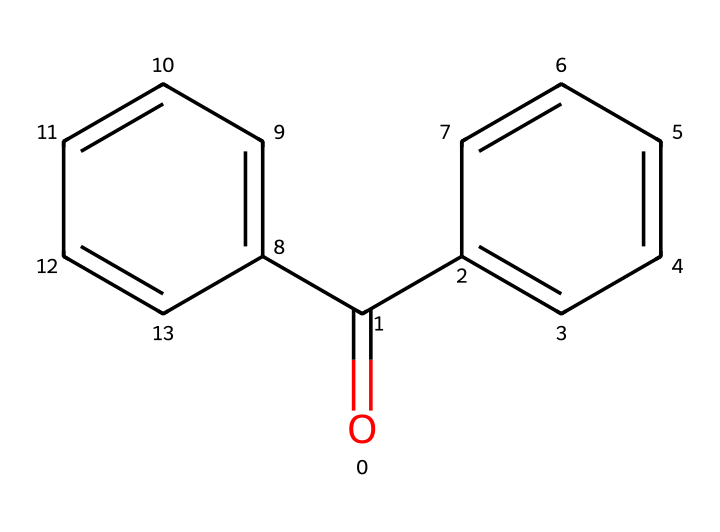What is the core functional group in this structure? The structure contains a carbonyl group (C=O) which is indicative of ketones or aldehydes, but in this case, it is part of a ketone due to the arrangement with benzene rings.
Answer: carbonyl How many benzene rings are present in the structure? By analyzing the structure, we can see two distinct benzene rings (c1ccccc1 and c2ccccc2) attached to the carbonyl group.
Answer: two What is the molecular formula derived from the chemical structure? The SMILES notation can be converted into a molecular formula by counting the carbon and hydrogen atoms: there are 13 carbons (C) and 10 hydrogens (H), along with one oxygen (O) in the structure, yielding C13H10O.
Answer: C13H10O What type of compound does this structure represent? The presence of the carbonyl group and two aromatic rings suggests this compound is an aromatic ketone, specifically a photoinitiator in photoresists.
Answer: aromatic ketone What is the significance of the carbonyl group in photoinitiators? The carbonyl group (C=O) in the structure plays a critical role in absorbing UV light, which subsequently initiates polymerization in photoresists, leading to enhanced light sensitivity.
Answer: absorbs UV light 